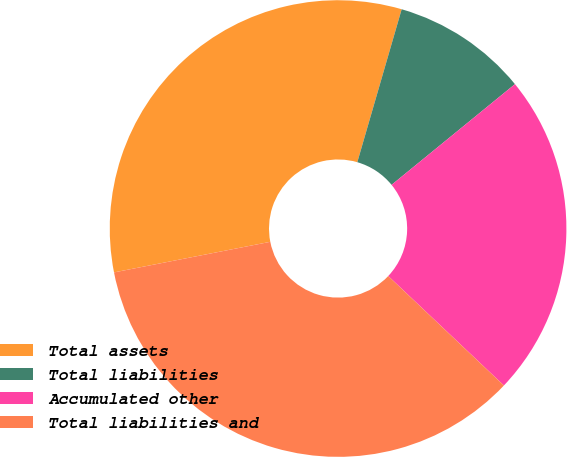<chart> <loc_0><loc_0><loc_500><loc_500><pie_chart><fcel>Total assets<fcel>Total liabilities<fcel>Accumulated other<fcel>Total liabilities and<nl><fcel>32.57%<fcel>9.61%<fcel>22.96%<fcel>34.86%<nl></chart> 